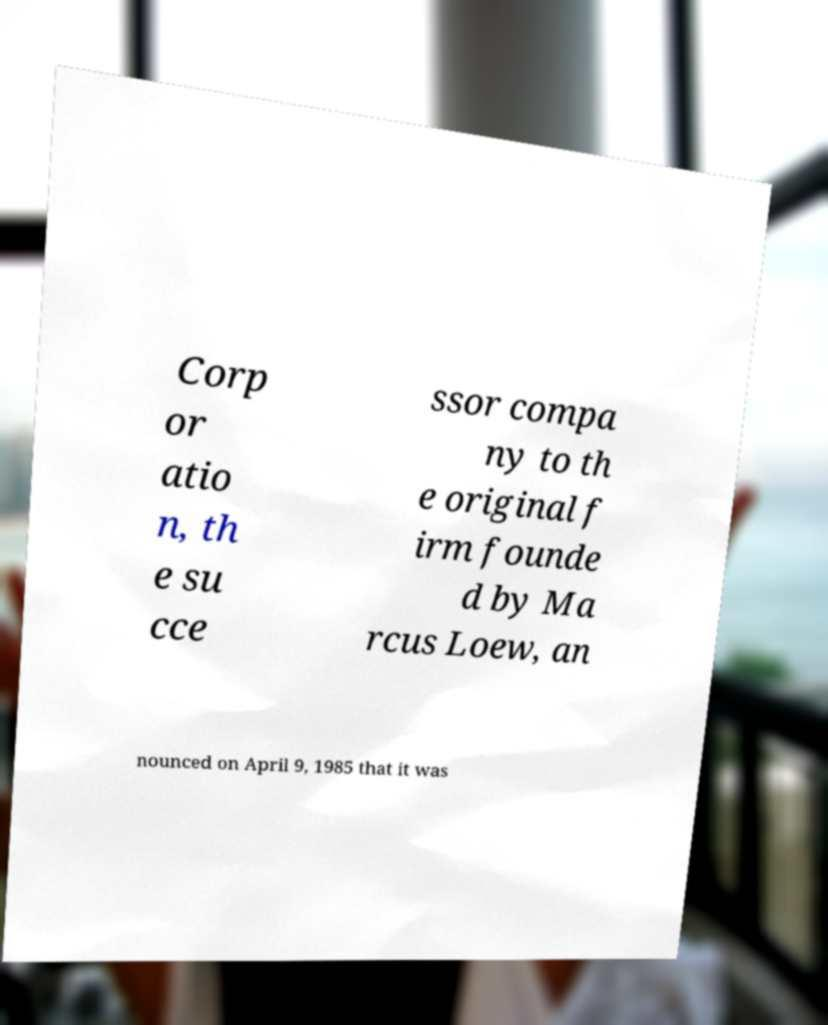What messages or text are displayed in this image? I need them in a readable, typed format. Corp or atio n, th e su cce ssor compa ny to th e original f irm founde d by Ma rcus Loew, an nounced on April 9, 1985 that it was 